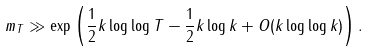Convert formula to latex. <formula><loc_0><loc_0><loc_500><loc_500>m _ { T } \gg \exp \left ( \frac { 1 } { 2 } k \log \log T - \frac { 1 } { 2 } k \log k + O ( k \log \log k ) \right ) .</formula> 